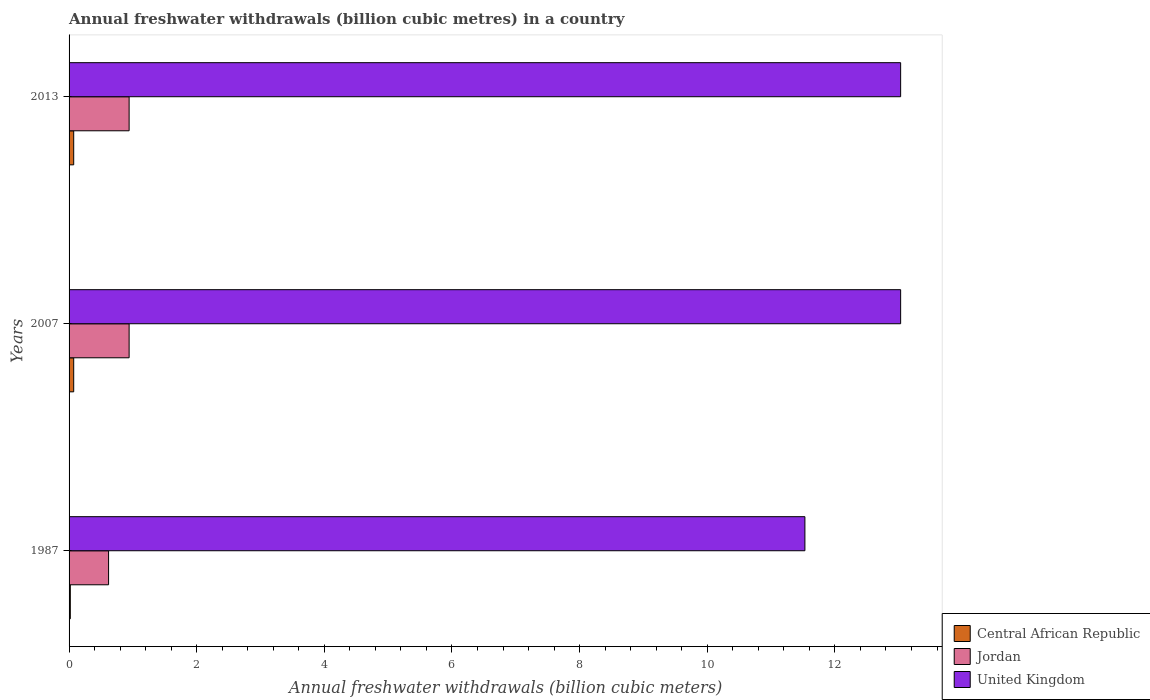Are the number of bars per tick equal to the number of legend labels?
Provide a short and direct response. Yes. Are the number of bars on each tick of the Y-axis equal?
Offer a terse response. Yes. How many bars are there on the 1st tick from the bottom?
Your answer should be very brief. 3. In how many cases, is the number of bars for a given year not equal to the number of legend labels?
Offer a very short reply. 0. What is the annual freshwater withdrawals in United Kingdom in 1987?
Your answer should be very brief. 11.53. Across all years, what is the maximum annual freshwater withdrawals in Jordan?
Your answer should be very brief. 0.94. Across all years, what is the minimum annual freshwater withdrawals in Jordan?
Ensure brevity in your answer.  0.62. What is the total annual freshwater withdrawals in Jordan in the graph?
Offer a terse response. 2.5. What is the difference between the annual freshwater withdrawals in Jordan in 1987 and that in 2013?
Ensure brevity in your answer.  -0.32. What is the difference between the annual freshwater withdrawals in Jordan in 2013 and the annual freshwater withdrawals in Central African Republic in 2007?
Provide a succinct answer. 0.87. What is the average annual freshwater withdrawals in United Kingdom per year?
Your answer should be very brief. 12.53. In the year 2013, what is the difference between the annual freshwater withdrawals in United Kingdom and annual freshwater withdrawals in Central African Republic?
Keep it short and to the point. 12.96. What is the ratio of the annual freshwater withdrawals in United Kingdom in 1987 to that in 2007?
Provide a short and direct response. 0.88. Is the difference between the annual freshwater withdrawals in United Kingdom in 2007 and 2013 greater than the difference between the annual freshwater withdrawals in Central African Republic in 2007 and 2013?
Offer a terse response. No. What is the difference between the highest and the second highest annual freshwater withdrawals in United Kingdom?
Keep it short and to the point. 0. In how many years, is the annual freshwater withdrawals in United Kingdom greater than the average annual freshwater withdrawals in United Kingdom taken over all years?
Your response must be concise. 2. Is the sum of the annual freshwater withdrawals in Jordan in 1987 and 2007 greater than the maximum annual freshwater withdrawals in Central African Republic across all years?
Your answer should be very brief. Yes. Are all the bars in the graph horizontal?
Ensure brevity in your answer.  Yes. How many years are there in the graph?
Provide a succinct answer. 3. Does the graph contain any zero values?
Offer a terse response. No. How are the legend labels stacked?
Your answer should be very brief. Vertical. What is the title of the graph?
Your answer should be very brief. Annual freshwater withdrawals (billion cubic metres) in a country. Does "Togo" appear as one of the legend labels in the graph?
Give a very brief answer. No. What is the label or title of the X-axis?
Ensure brevity in your answer.  Annual freshwater withdrawals (billion cubic meters). What is the Annual freshwater withdrawals (billion cubic meters) in Central African Republic in 1987?
Provide a short and direct response. 0.02. What is the Annual freshwater withdrawals (billion cubic meters) of Jordan in 1987?
Provide a succinct answer. 0.62. What is the Annual freshwater withdrawals (billion cubic meters) in United Kingdom in 1987?
Your response must be concise. 11.53. What is the Annual freshwater withdrawals (billion cubic meters) of Central African Republic in 2007?
Offer a very short reply. 0.07. What is the Annual freshwater withdrawals (billion cubic meters) of Jordan in 2007?
Offer a very short reply. 0.94. What is the Annual freshwater withdrawals (billion cubic meters) of United Kingdom in 2007?
Provide a short and direct response. 13.03. What is the Annual freshwater withdrawals (billion cubic meters) in Central African Republic in 2013?
Provide a succinct answer. 0.07. What is the Annual freshwater withdrawals (billion cubic meters) in Jordan in 2013?
Your response must be concise. 0.94. What is the Annual freshwater withdrawals (billion cubic meters) of United Kingdom in 2013?
Ensure brevity in your answer.  13.03. Across all years, what is the maximum Annual freshwater withdrawals (billion cubic meters) in Central African Republic?
Your answer should be compact. 0.07. Across all years, what is the maximum Annual freshwater withdrawals (billion cubic meters) in Jordan?
Your answer should be very brief. 0.94. Across all years, what is the maximum Annual freshwater withdrawals (billion cubic meters) of United Kingdom?
Make the answer very short. 13.03. Across all years, what is the minimum Annual freshwater withdrawals (billion cubic meters) in Central African Republic?
Your answer should be very brief. 0.02. Across all years, what is the minimum Annual freshwater withdrawals (billion cubic meters) in Jordan?
Provide a short and direct response. 0.62. Across all years, what is the minimum Annual freshwater withdrawals (billion cubic meters) in United Kingdom?
Ensure brevity in your answer.  11.53. What is the total Annual freshwater withdrawals (billion cubic meters) of Central African Republic in the graph?
Give a very brief answer. 0.16. What is the total Annual freshwater withdrawals (billion cubic meters) of Jordan in the graph?
Provide a succinct answer. 2.5. What is the total Annual freshwater withdrawals (billion cubic meters) in United Kingdom in the graph?
Keep it short and to the point. 37.59. What is the difference between the Annual freshwater withdrawals (billion cubic meters) of Central African Republic in 1987 and that in 2007?
Provide a succinct answer. -0.05. What is the difference between the Annual freshwater withdrawals (billion cubic meters) in Jordan in 1987 and that in 2007?
Your answer should be compact. -0.32. What is the difference between the Annual freshwater withdrawals (billion cubic meters) in Central African Republic in 1987 and that in 2013?
Provide a short and direct response. -0.05. What is the difference between the Annual freshwater withdrawals (billion cubic meters) of Jordan in 1987 and that in 2013?
Your answer should be very brief. -0.32. What is the difference between the Annual freshwater withdrawals (billion cubic meters) in Jordan in 2007 and that in 2013?
Your answer should be compact. 0. What is the difference between the Annual freshwater withdrawals (billion cubic meters) in Central African Republic in 1987 and the Annual freshwater withdrawals (billion cubic meters) in Jordan in 2007?
Your response must be concise. -0.92. What is the difference between the Annual freshwater withdrawals (billion cubic meters) of Central African Republic in 1987 and the Annual freshwater withdrawals (billion cubic meters) of United Kingdom in 2007?
Your response must be concise. -13.01. What is the difference between the Annual freshwater withdrawals (billion cubic meters) in Jordan in 1987 and the Annual freshwater withdrawals (billion cubic meters) in United Kingdom in 2007?
Your answer should be very brief. -12.41. What is the difference between the Annual freshwater withdrawals (billion cubic meters) of Central African Republic in 1987 and the Annual freshwater withdrawals (billion cubic meters) of Jordan in 2013?
Ensure brevity in your answer.  -0.92. What is the difference between the Annual freshwater withdrawals (billion cubic meters) of Central African Republic in 1987 and the Annual freshwater withdrawals (billion cubic meters) of United Kingdom in 2013?
Keep it short and to the point. -13.01. What is the difference between the Annual freshwater withdrawals (billion cubic meters) in Jordan in 1987 and the Annual freshwater withdrawals (billion cubic meters) in United Kingdom in 2013?
Keep it short and to the point. -12.41. What is the difference between the Annual freshwater withdrawals (billion cubic meters) in Central African Republic in 2007 and the Annual freshwater withdrawals (billion cubic meters) in Jordan in 2013?
Keep it short and to the point. -0.87. What is the difference between the Annual freshwater withdrawals (billion cubic meters) in Central African Republic in 2007 and the Annual freshwater withdrawals (billion cubic meters) in United Kingdom in 2013?
Provide a short and direct response. -12.96. What is the difference between the Annual freshwater withdrawals (billion cubic meters) of Jordan in 2007 and the Annual freshwater withdrawals (billion cubic meters) of United Kingdom in 2013?
Make the answer very short. -12.09. What is the average Annual freshwater withdrawals (billion cubic meters) of Central African Republic per year?
Ensure brevity in your answer.  0.05. What is the average Annual freshwater withdrawals (billion cubic meters) in Jordan per year?
Keep it short and to the point. 0.83. What is the average Annual freshwater withdrawals (billion cubic meters) of United Kingdom per year?
Provide a short and direct response. 12.53. In the year 1987, what is the difference between the Annual freshwater withdrawals (billion cubic meters) of Central African Republic and Annual freshwater withdrawals (billion cubic meters) of Jordan?
Offer a terse response. -0.6. In the year 1987, what is the difference between the Annual freshwater withdrawals (billion cubic meters) of Central African Republic and Annual freshwater withdrawals (billion cubic meters) of United Kingdom?
Offer a very short reply. -11.51. In the year 1987, what is the difference between the Annual freshwater withdrawals (billion cubic meters) of Jordan and Annual freshwater withdrawals (billion cubic meters) of United Kingdom?
Provide a short and direct response. -10.91. In the year 2007, what is the difference between the Annual freshwater withdrawals (billion cubic meters) in Central African Republic and Annual freshwater withdrawals (billion cubic meters) in Jordan?
Provide a short and direct response. -0.87. In the year 2007, what is the difference between the Annual freshwater withdrawals (billion cubic meters) in Central African Republic and Annual freshwater withdrawals (billion cubic meters) in United Kingdom?
Keep it short and to the point. -12.96. In the year 2007, what is the difference between the Annual freshwater withdrawals (billion cubic meters) of Jordan and Annual freshwater withdrawals (billion cubic meters) of United Kingdom?
Provide a short and direct response. -12.09. In the year 2013, what is the difference between the Annual freshwater withdrawals (billion cubic meters) of Central African Republic and Annual freshwater withdrawals (billion cubic meters) of Jordan?
Ensure brevity in your answer.  -0.87. In the year 2013, what is the difference between the Annual freshwater withdrawals (billion cubic meters) in Central African Republic and Annual freshwater withdrawals (billion cubic meters) in United Kingdom?
Provide a short and direct response. -12.96. In the year 2013, what is the difference between the Annual freshwater withdrawals (billion cubic meters) in Jordan and Annual freshwater withdrawals (billion cubic meters) in United Kingdom?
Provide a short and direct response. -12.09. What is the ratio of the Annual freshwater withdrawals (billion cubic meters) of Central African Republic in 1987 to that in 2007?
Keep it short and to the point. 0.27. What is the ratio of the Annual freshwater withdrawals (billion cubic meters) in Jordan in 1987 to that in 2007?
Your answer should be compact. 0.66. What is the ratio of the Annual freshwater withdrawals (billion cubic meters) in United Kingdom in 1987 to that in 2007?
Your response must be concise. 0.88. What is the ratio of the Annual freshwater withdrawals (billion cubic meters) of Central African Republic in 1987 to that in 2013?
Offer a very short reply. 0.27. What is the ratio of the Annual freshwater withdrawals (billion cubic meters) in Jordan in 1987 to that in 2013?
Give a very brief answer. 0.66. What is the ratio of the Annual freshwater withdrawals (billion cubic meters) in United Kingdom in 1987 to that in 2013?
Provide a succinct answer. 0.88. What is the ratio of the Annual freshwater withdrawals (billion cubic meters) of United Kingdom in 2007 to that in 2013?
Ensure brevity in your answer.  1. What is the difference between the highest and the second highest Annual freshwater withdrawals (billion cubic meters) of Central African Republic?
Offer a very short reply. 0. What is the difference between the highest and the second highest Annual freshwater withdrawals (billion cubic meters) of United Kingdom?
Provide a short and direct response. 0. What is the difference between the highest and the lowest Annual freshwater withdrawals (billion cubic meters) in Central African Republic?
Make the answer very short. 0.05. What is the difference between the highest and the lowest Annual freshwater withdrawals (billion cubic meters) in Jordan?
Your answer should be compact. 0.32. What is the difference between the highest and the lowest Annual freshwater withdrawals (billion cubic meters) of United Kingdom?
Give a very brief answer. 1.5. 